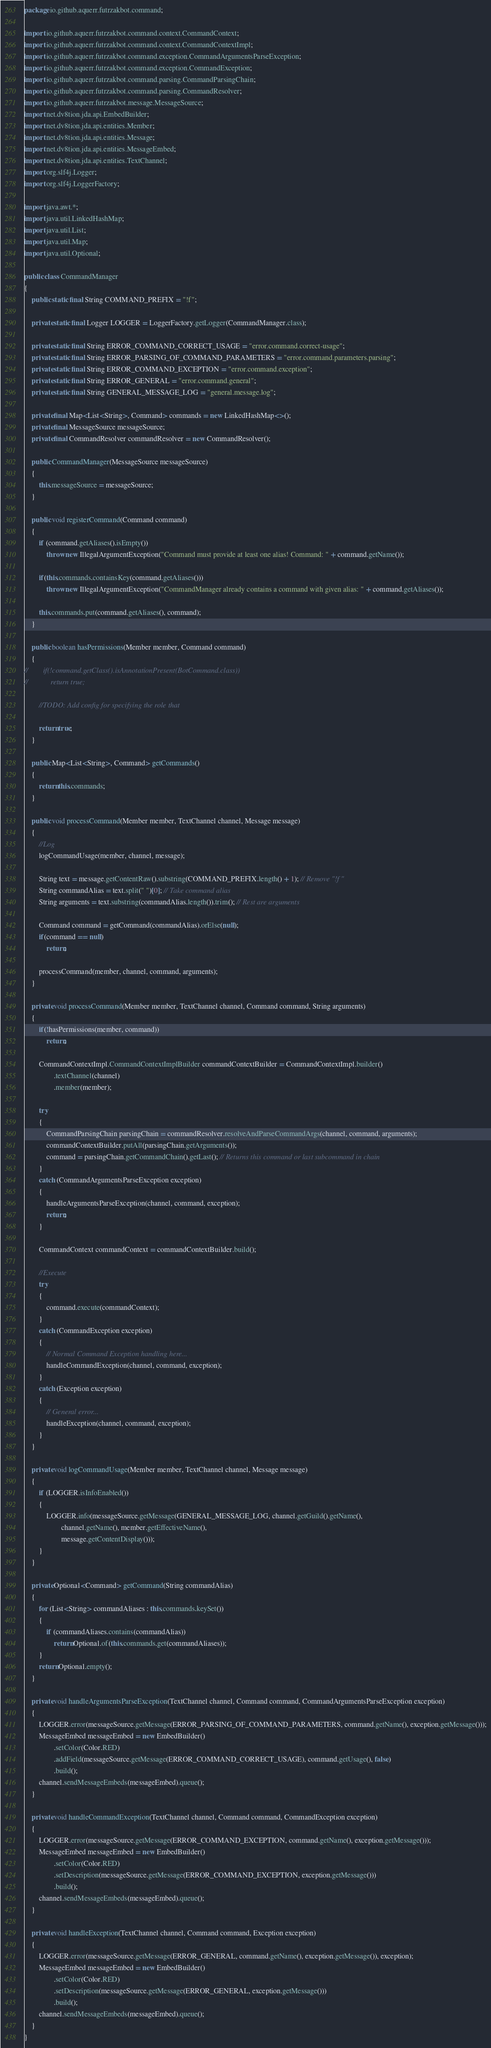Convert code to text. <code><loc_0><loc_0><loc_500><loc_500><_Java_>package io.github.aquerr.futrzakbot.command;

import io.github.aquerr.futrzakbot.command.context.CommandContext;
import io.github.aquerr.futrzakbot.command.context.CommandContextImpl;
import io.github.aquerr.futrzakbot.command.exception.CommandArgumentsParseException;
import io.github.aquerr.futrzakbot.command.exception.CommandException;
import io.github.aquerr.futrzakbot.command.parsing.CommandParsingChain;
import io.github.aquerr.futrzakbot.command.parsing.CommandResolver;
import io.github.aquerr.futrzakbot.message.MessageSource;
import net.dv8tion.jda.api.EmbedBuilder;
import net.dv8tion.jda.api.entities.Member;
import net.dv8tion.jda.api.entities.Message;
import net.dv8tion.jda.api.entities.MessageEmbed;
import net.dv8tion.jda.api.entities.TextChannel;
import org.slf4j.Logger;
import org.slf4j.LoggerFactory;

import java.awt.*;
import java.util.LinkedHashMap;
import java.util.List;
import java.util.Map;
import java.util.Optional;

public class CommandManager
{
    public static final String COMMAND_PREFIX = "!f";

    private static final Logger LOGGER = LoggerFactory.getLogger(CommandManager.class);

    private static final String ERROR_COMMAND_CORRECT_USAGE = "error.command.correct-usage";
    private static final String ERROR_PARSING_OF_COMMAND_PARAMETERS = "error.command.parameters.parsing";
    private static final String ERROR_COMMAND_EXCEPTION = "error.command.exception";
    private static final String ERROR_GENERAL = "error.command.general";
    private static final String GENERAL_MESSAGE_LOG = "general.message.log";

    private final Map<List<String>, Command> commands = new LinkedHashMap<>();
    private final MessageSource messageSource;
    private final CommandResolver commandResolver = new CommandResolver();

    public CommandManager(MessageSource messageSource)
    {
        this.messageSource = messageSource;
    }

    public void registerCommand(Command command)
    {
        if (command.getAliases().isEmpty())
            throw new IllegalArgumentException("Command must provide at least one alias! Command: " + command.getName());

        if(this.commands.containsKey(command.getAliases()))
            throw new IllegalArgumentException("CommandManager already contains a command with given alias: " + command.getAliases());

        this.commands.put(command.getAliases(), command);
    }

    public boolean hasPermissions(Member member, Command command)
    {
//        if(!command.getClass().isAnnotationPresent(BotCommand.class))
//            return true;

        //TODO: Add config for specifying the role that

        return true;
    }

    public Map<List<String>, Command> getCommands()
    {
        return this.commands;
    }

    public void processCommand(Member member, TextChannel channel, Message message)
    {
        //Log
        logCommandUsage(member, channel, message);

        String text = message.getContentRaw().substring(COMMAND_PREFIX.length() + 1); // Remove "!f "
        String commandAlias = text.split(" ")[0]; // Take command alias
        String arguments = text.substring(commandAlias.length()).trim(); // Rest are arguments

        Command command = getCommand(commandAlias).orElse(null);
        if(command == null)
            return;

        processCommand(member, channel, command, arguments);
    }

    private void processCommand(Member member, TextChannel channel, Command command, String arguments)
    {
        if(!hasPermissions(member, command))
            return;

        CommandContextImpl.CommandContextImplBuilder commandContextBuilder = CommandContextImpl.builder()
                .textChannel(channel)
                .member(member);

        try
        {
            CommandParsingChain parsingChain = commandResolver.resolveAndParseCommandArgs(channel, command, arguments);
            commandContextBuilder.putAll(parsingChain.getArguments());
            command = parsingChain.getCommandChain().getLast(); // Returns this command or last subcommand in chain
        }
        catch (CommandArgumentsParseException exception)
        {
            handleArgumentsParseException(channel, command, exception);
            return;
        }

        CommandContext commandContext = commandContextBuilder.build();

        //Execute
        try
        {
            command.execute(commandContext);
        }
        catch (CommandException exception)
        {
            // Normal Command Exception handling here...
            handleCommandException(channel, command, exception);
        }
        catch (Exception exception)
        {
            // General error...
            handleException(channel, command, exception);
        }
    }

    private void logCommandUsage(Member member, TextChannel channel, Message message)
    {
        if (LOGGER.isInfoEnabled())
        {
            LOGGER.info(messageSource.getMessage(GENERAL_MESSAGE_LOG, channel.getGuild().getName(),
                    channel.getName(), member.getEffectiveName(),
                    message.getContentDisplay()));
        }
    }

    private Optional<Command> getCommand(String commandAlias)
    {
        for (List<String> commandAliases : this.commands.keySet())
        {
            if (commandAliases.contains(commandAlias))
                return Optional.of(this.commands.get(commandAliases));
        }
        return Optional.empty();
    }

    private void handleArgumentsParseException(TextChannel channel, Command command, CommandArgumentsParseException exception)
    {
        LOGGER.error(messageSource.getMessage(ERROR_PARSING_OF_COMMAND_PARAMETERS, command.getName(), exception.getMessage()));
        MessageEmbed messageEmbed = new EmbedBuilder()
                .setColor(Color.RED)
                .addField(messageSource.getMessage(ERROR_COMMAND_CORRECT_USAGE), command.getUsage(), false)
                .build();
        channel.sendMessageEmbeds(messageEmbed).queue();
    }

    private void handleCommandException(TextChannel channel, Command command, CommandException exception)
    {
        LOGGER.error(messageSource.getMessage(ERROR_COMMAND_EXCEPTION, command.getName(), exception.getMessage()));
        MessageEmbed messageEmbed = new EmbedBuilder()
                .setColor(Color.RED)
                .setDescription(messageSource.getMessage(ERROR_COMMAND_EXCEPTION, exception.getMessage()))
                .build();
        channel.sendMessageEmbeds(messageEmbed).queue();
    }

    private void handleException(TextChannel channel, Command command, Exception exception)
    {
        LOGGER.error(messageSource.getMessage(ERROR_GENERAL, command.getName(), exception.getMessage()), exception);
        MessageEmbed messageEmbed = new EmbedBuilder()
                .setColor(Color.RED)
                .setDescription(messageSource.getMessage(ERROR_GENERAL, exception.getMessage()))
                .build();
        channel.sendMessageEmbeds(messageEmbed).queue();
    }
}</code> 